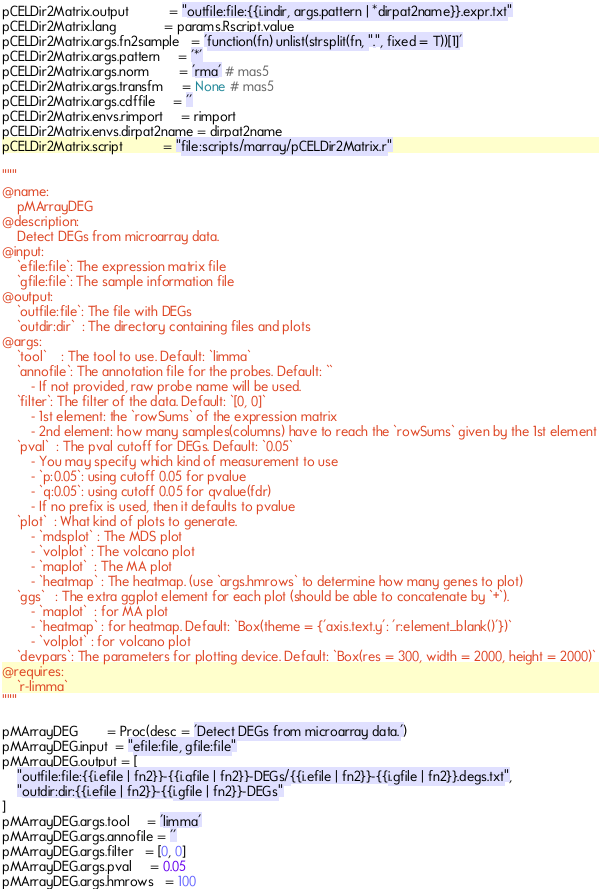<code> <loc_0><loc_0><loc_500><loc_500><_Python_>pCELDir2Matrix.output           = "outfile:file:{{i.indir, args.pattern | *dirpat2name}}.expr.txt"
pCELDir2Matrix.lang             = params.Rscript.value
pCELDir2Matrix.args.fn2sample   = 'function(fn) unlist(strsplit(fn, ".", fixed = T))[1]'
pCELDir2Matrix.args.pattern     = '*'
pCELDir2Matrix.args.norm        = 'rma' # mas5
pCELDir2Matrix.args.transfm     = None # mas5
pCELDir2Matrix.args.cdffile     = ''
pCELDir2Matrix.envs.rimport     = rimport
pCELDir2Matrix.envs.dirpat2name = dirpat2name
pCELDir2Matrix.script           = "file:scripts/marray/pCELDir2Matrix.r"

"""
@name:
	pMArrayDEG
@description:
	Detect DEGs from microarray data.
@input:
	`efile:file`: The expression matrix file
	`gfile:file`: The sample information file
@output:
	`outfile:file`: The file with DEGs
	`outdir:dir`  : The directory containing files and plots
@args:
	`tool`    : The tool to use. Default: `limma`
	`annofile`: The annotation file for the probes. Default: ``
		- If not provided, raw probe name will be used.
	`filter`: The filter of the data. Default: `[0, 0]`
		- 1st element: the `rowSums` of the expression matrix
		- 2nd element: how many samples(columns) have to reach the `rowSums` given by the 1st element
	`pval`  : The pval cutoff for DEGs. Default: `0.05`
		- You may specify which kind of measurement to use
		- `p:0.05`: using cutoff 0.05 for pvalue
		- `q:0.05`: using cutoff 0.05 for qvalue(fdr)
		- If no prefix is used, then it defaults to pvalue
	`plot`  : What kind of plots to generate. 
		- `mdsplot` : The MDS plot
		- `volplot` : The volcano plot
		- `maplot`  : The MA plot
		- `heatmap` : The heatmap. (use `args.hmrows` to determine how many genes to plot)
	`ggs`   : The extra ggplot element for each plot (should be able to concatenate by `+`).
		- `maplot`  : for MA plot
		- `heatmap` : for heatmap. Default: `Box(theme = {'axis.text.y': 'r:element_blank()'})`
		- `volplot` : for volcano plot
	`devpars`: The parameters for plotting device. Default: `Box(res = 300, width = 2000, height = 2000)`
@requires:
	`r-limma`
"""

pMArrayDEG        = Proc(desc = 'Detect DEGs from microarray data.')
pMArrayDEG.input  = "efile:file, gfile:file"
pMArrayDEG.output = [
	"outfile:file:{{i.efile | fn2}}-{{i.gfile | fn2}}-DEGs/{{i.efile | fn2}}-{{i.gfile | fn2}}.degs.txt",
	"outdir:dir:{{i.efile | fn2}}-{{i.gfile | fn2}}-DEGs"
]
pMArrayDEG.args.tool     = 'limma'
pMArrayDEG.args.annofile = ''
pMArrayDEG.args.filter   = [0, 0]
pMArrayDEG.args.pval     = 0.05
pMArrayDEG.args.hmrows   = 100</code> 